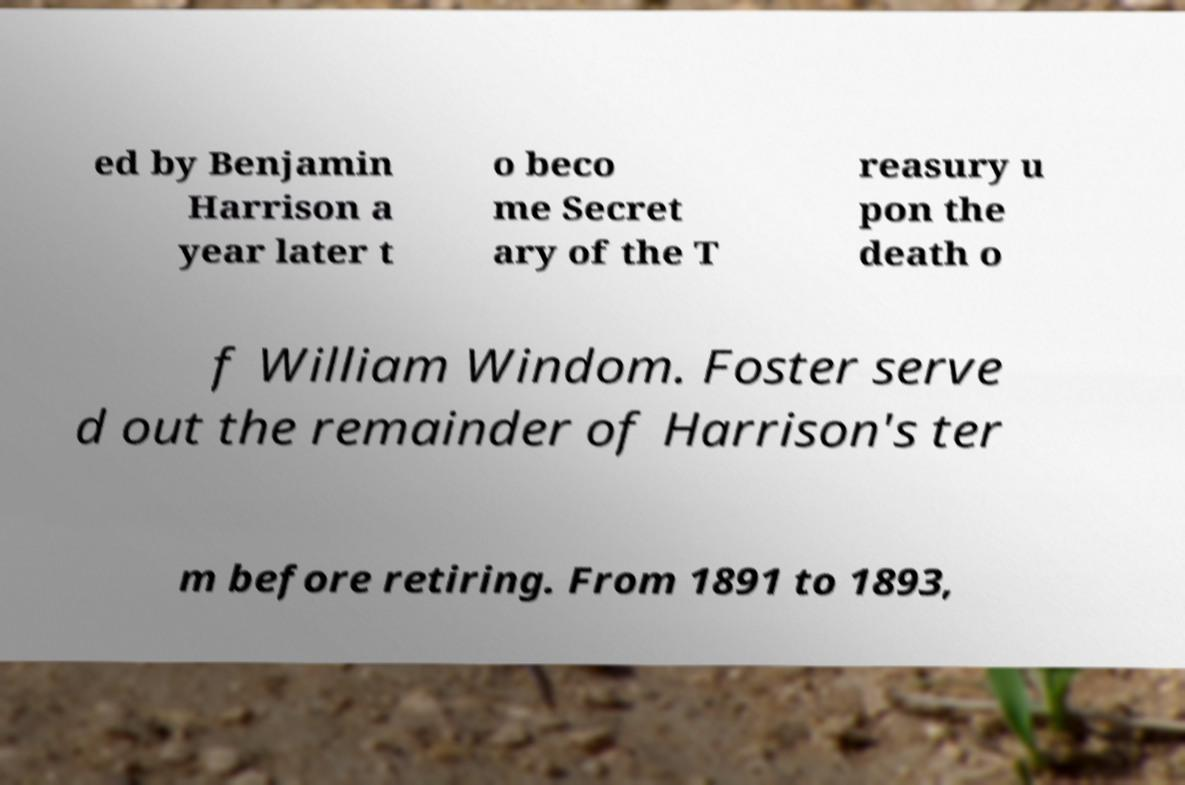Can you accurately transcribe the text from the provided image for me? ed by Benjamin Harrison a year later t o beco me Secret ary of the T reasury u pon the death o f William Windom. Foster serve d out the remainder of Harrison's ter m before retiring. From 1891 to 1893, 